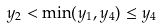<formula> <loc_0><loc_0><loc_500><loc_500>y _ { 2 } < \min ( y _ { 1 } , y _ { 4 } ) \leq y _ { 4 }</formula> 